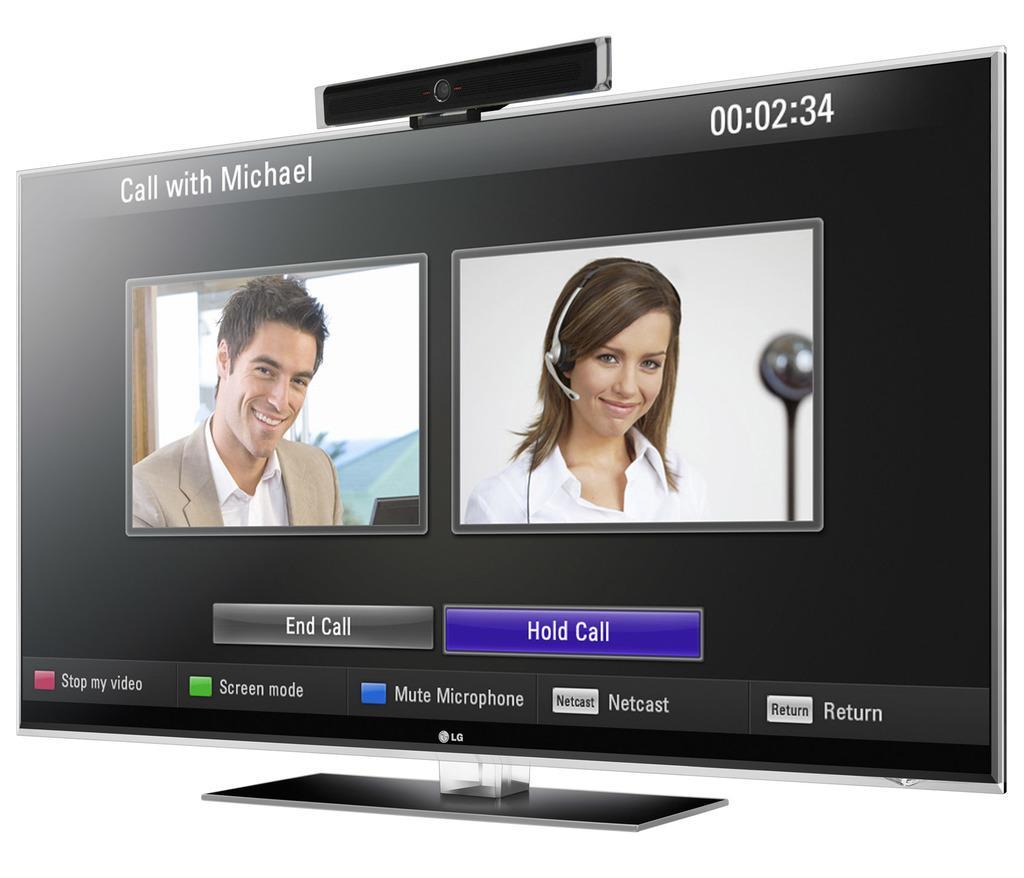How would you summarize this image in a sentence or two? In the picture I can see the television in which I can see an image of a man and woman are displayed and I can see some icons and the background of the image is in white color. 